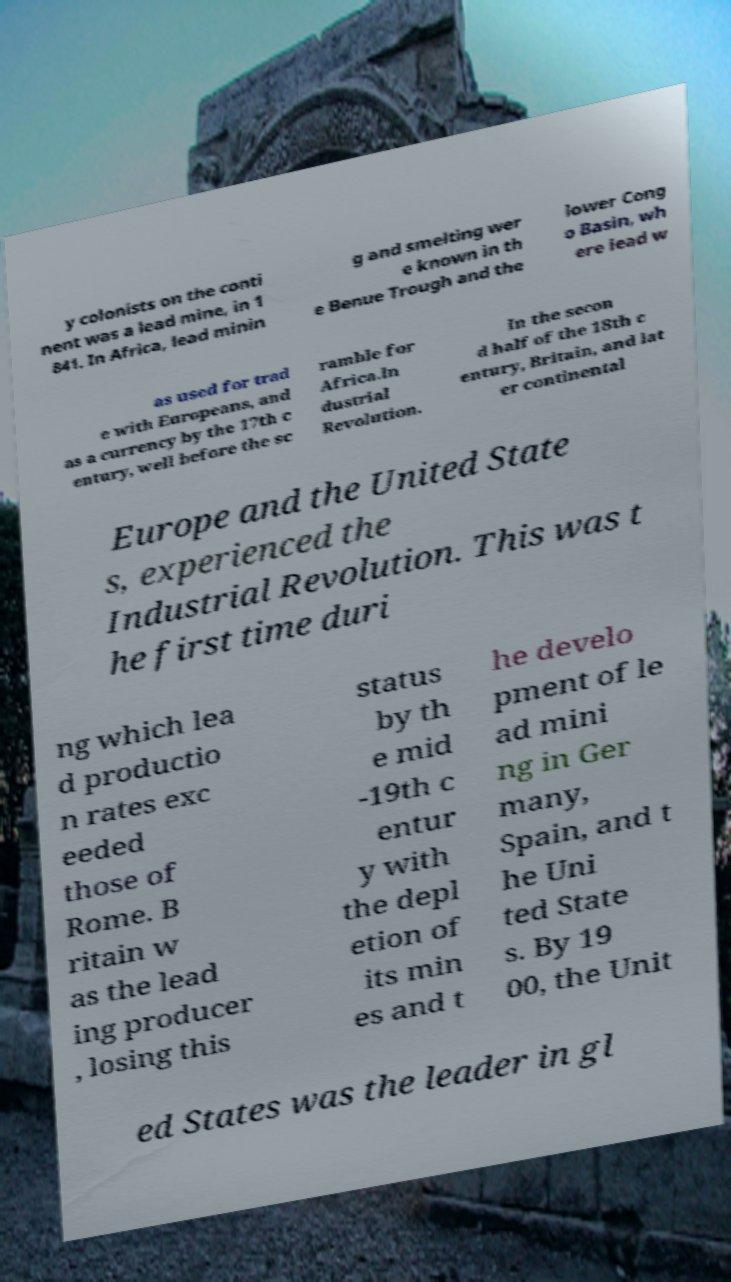What messages or text are displayed in this image? I need them in a readable, typed format. y colonists on the conti nent was a lead mine, in 1 841. In Africa, lead minin g and smelting wer e known in th e Benue Trough and the lower Cong o Basin, wh ere lead w as used for trad e with Europeans, and as a currency by the 17th c entury, well before the sc ramble for Africa.In dustrial Revolution. In the secon d half of the 18th c entury, Britain, and lat er continental Europe and the United State s, experienced the Industrial Revolution. This was t he first time duri ng which lea d productio n rates exc eeded those of Rome. B ritain w as the lead ing producer , losing this status by th e mid -19th c entur y with the depl etion of its min es and t he develo pment of le ad mini ng in Ger many, Spain, and t he Uni ted State s. By 19 00, the Unit ed States was the leader in gl 